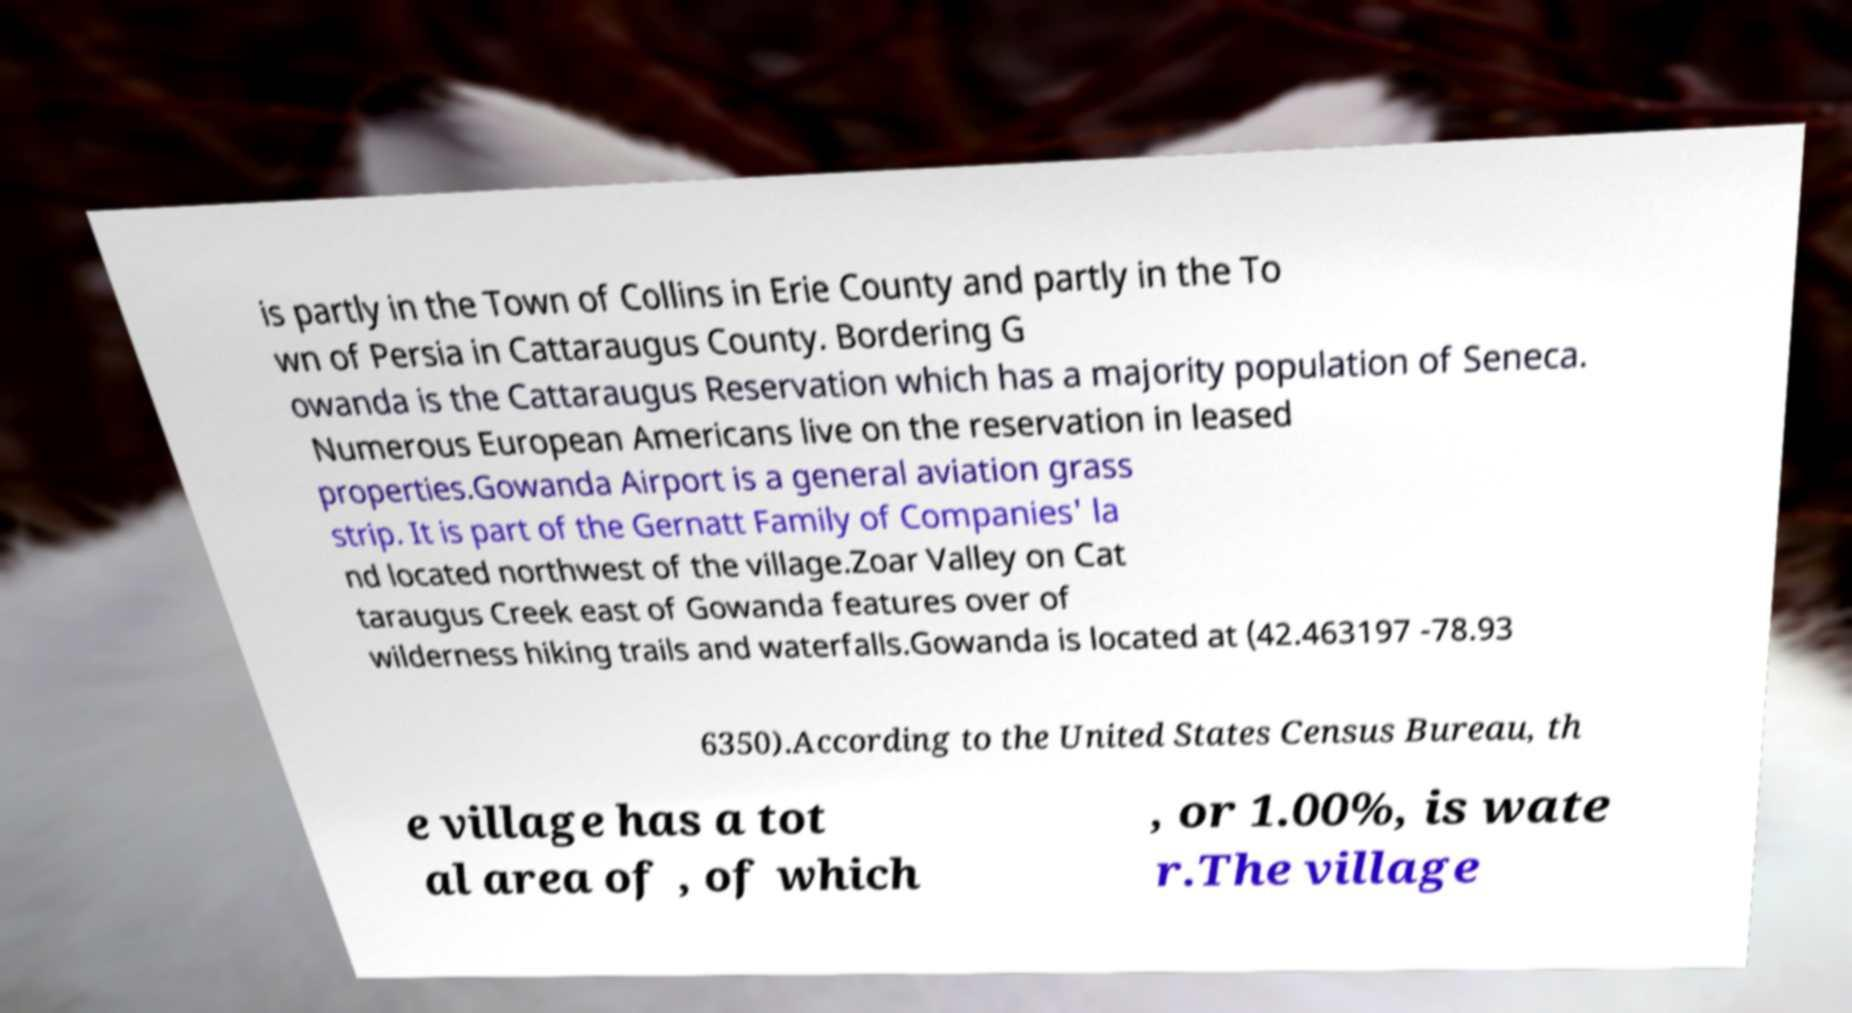Can you read and provide the text displayed in the image?This photo seems to have some interesting text. Can you extract and type it out for me? is partly in the Town of Collins in Erie County and partly in the To wn of Persia in Cattaraugus County. Bordering G owanda is the Cattaraugus Reservation which has a majority population of Seneca. Numerous European Americans live on the reservation in leased properties.Gowanda Airport is a general aviation grass strip. It is part of the Gernatt Family of Companies' la nd located northwest of the village.Zoar Valley on Cat taraugus Creek east of Gowanda features over of wilderness hiking trails and waterfalls.Gowanda is located at (42.463197 -78.93 6350).According to the United States Census Bureau, th e village has a tot al area of , of which , or 1.00%, is wate r.The village 